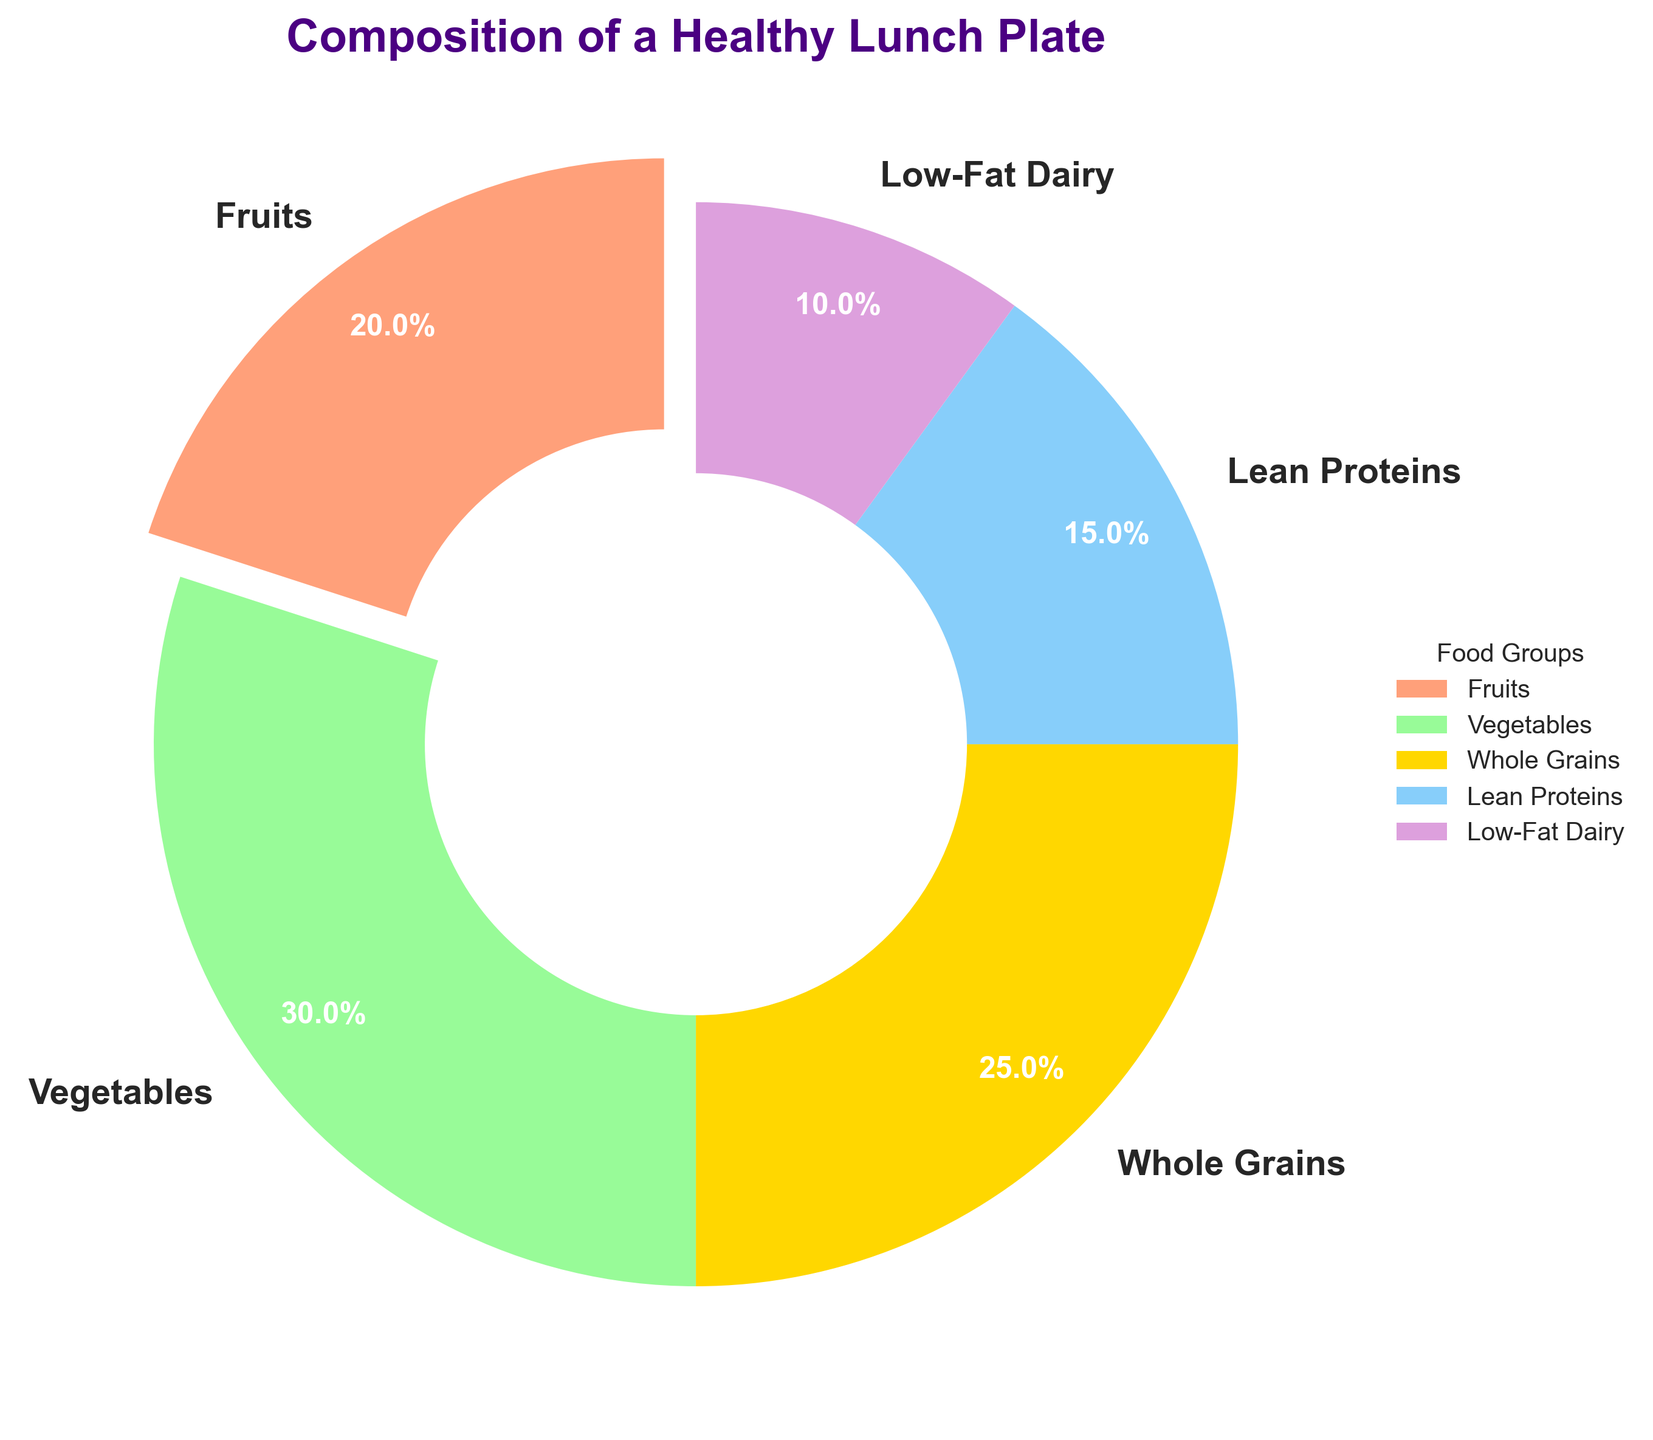What's the largest food group on the healthy lunch plate? The pie chart visually shows that the "Vegetables" section is the largest because it takes up more space than the other sections.
Answer: Vegetables What's the combined percentage of Lean Proteins and Low-Fat Dairy? According to the pie chart, Lean Proteins account for 15% and Low-Fat Dairy for 10%. Adding these two percentages together yields 15% + 10% = 25%.
Answer: 25% Which two food groups together make up more than half of the lunch plate? The pie chart shows that Vegetables are 30% and Whole Grains are 25%. Adding these two, the total is 30% + 25% = 55%, which is more than 50%.
Answer: Vegetables and Whole Grains Which category has the smallest representation and what is its percentage? The pie chart visually highlights that "Low-Fat Dairy" is the smallest section and its label shows 10%.
Answer: Low-Fat Dairy, 10% How many food groups occupy less than 20% of the space each? The pie chart indicates percentages for each group. By checking each value, only Lean Proteins (15%) and Low-Fat Dairy (10%) are less than 20%.
Answer: 2 What's the percentage difference between Whole Grains and Fruits? Whole Grains make up 25% and Fruits make up 20%, so the difference is 25% - 20% = 5%.
Answer: 5% Which food group is highlighted by being slightly separated from the rest of the pie? By looking at the visual separation in the pie chart, the "Fruits" section is slightly exploded or separated from the rest.
Answer: Fruits Between Lean Proteins and Whole Grains, which has a greater percentage, and by how much? According to the labels, Whole Grains are 25% and Lean Proteins are 15%. The difference is calculated as 25% - 15% = 10%.
Answer: Whole Grains, 10% What combined percentage do Fruits and Vegetables represent? Adding the percentages from the pie chart gives Fruits 20% and Vegetables 30%, so together they make up 20% + 30% = 50%.
Answer: 50% If the recommendation for Low-Fat Dairy were increased by 5%, what would its new percentage be? Starting with the given percentage for Low-Fat Dairy, which is 10%, adding 5% would result in 10% + 5% = 15%.
Answer: 15% 